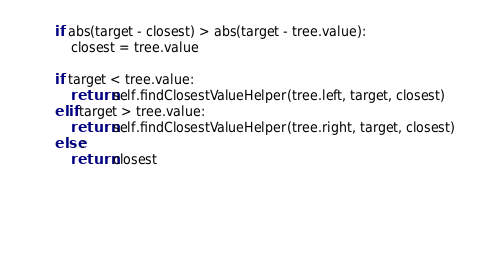<code> <loc_0><loc_0><loc_500><loc_500><_Python_>
		if abs(target - closest) > abs(target - tree.value):
			closest = tree.value

		if target < tree.value:
			return self.findClosestValueHelper(tree.left, target, closest)
		elif target > tree.value:
			return self.findClosestValueHelper(tree.right, target, closest)
		else:
			return closest

		

		</code> 